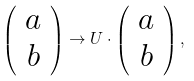Convert formula to latex. <formula><loc_0><loc_0><loc_500><loc_500>\left ( \begin{array} { c } { a } \\ { b } \end{array} \right ) \to U \cdot \left ( \begin{array} { c } { a } \\ { b } \end{array} \right ) ,</formula> 